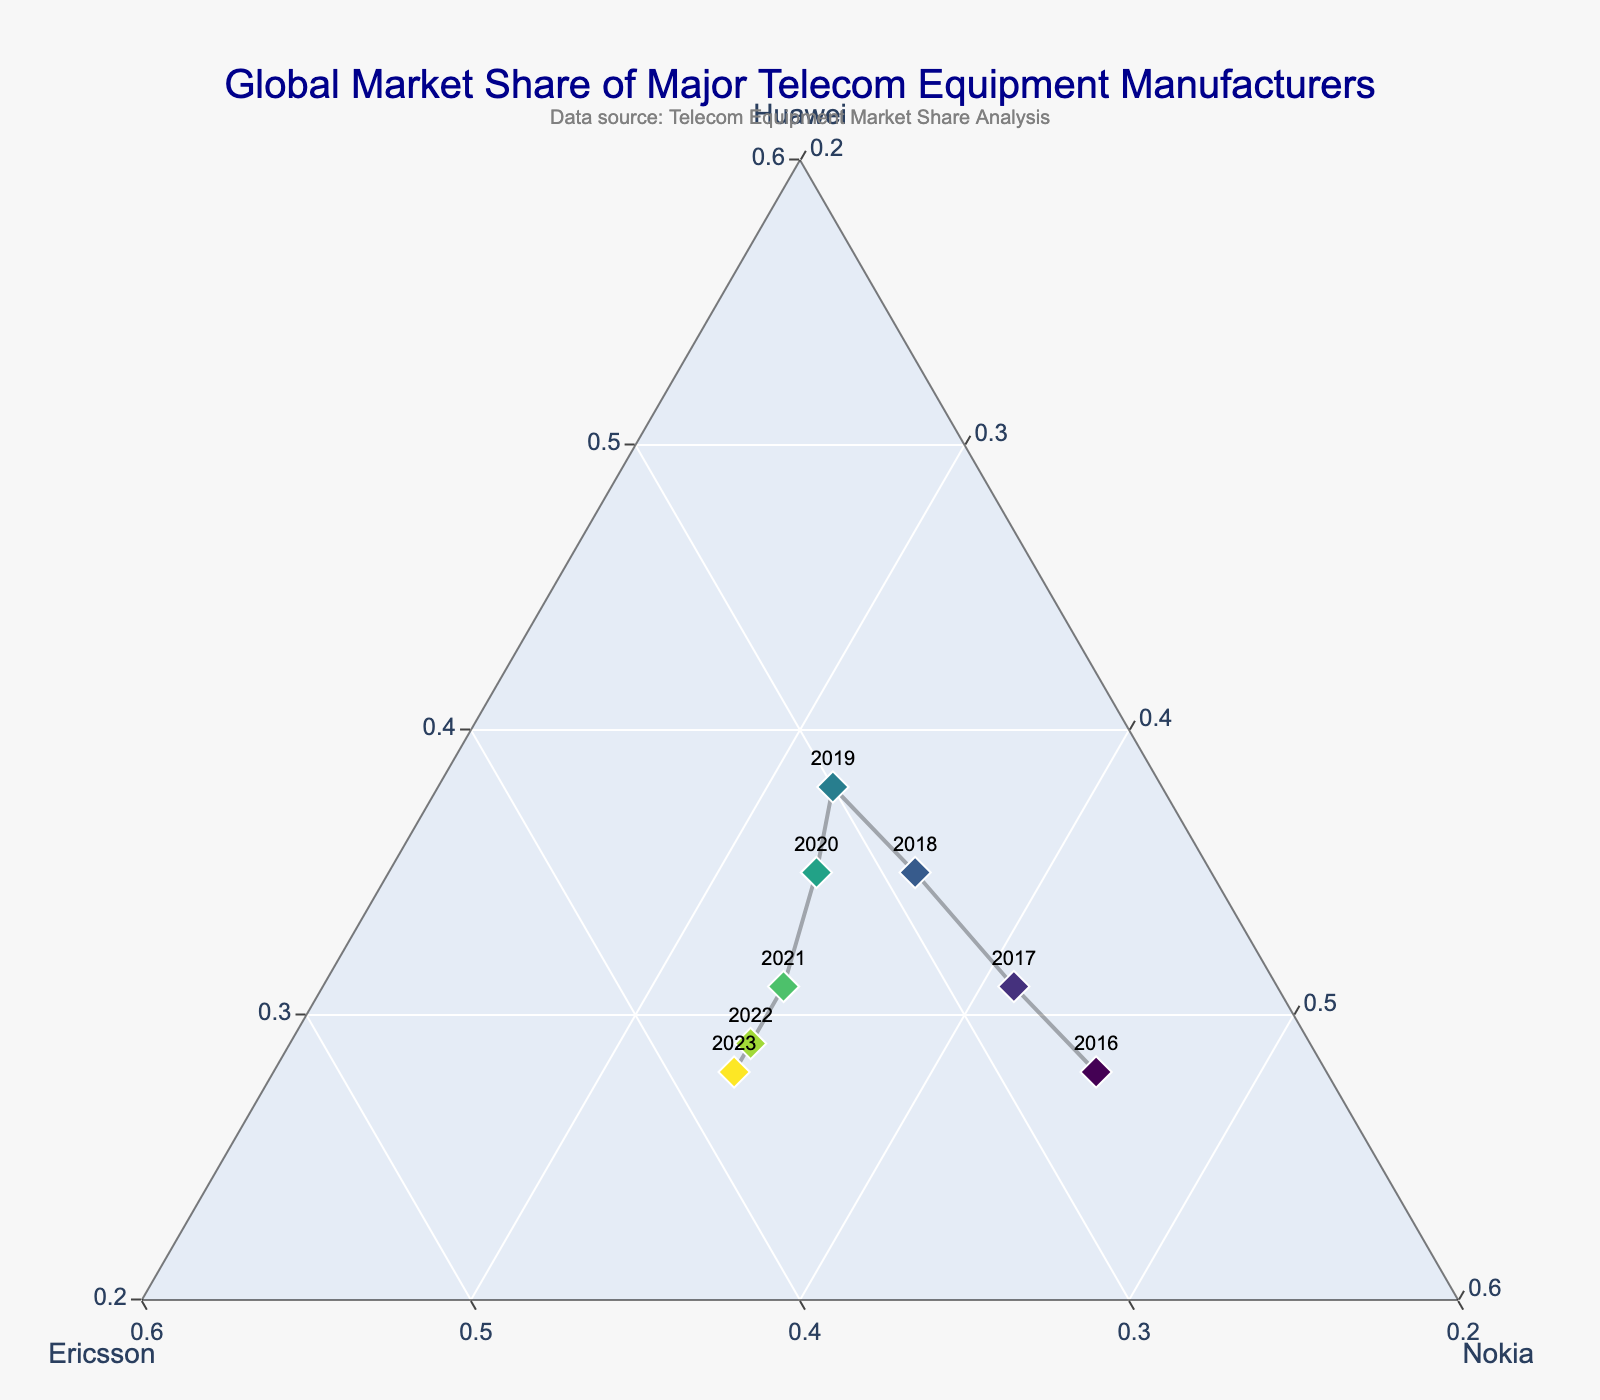What is the overall trend in Huawei’s market share from 2016 to 2023? To identify the trend, look at the position of each point labeled with the respective year. Huawei's share decreases after peaking around 2019, positioning closer to Nokia's axis in later years.
Answer: Decreasing How does Nokia's market share in 2023 compare to its share in 2016? Nokai’s market share is indicated by points' proximity to the Nokia axis. Compare the positions of the points labeled 2016 and 2023. Nokia's share slightly declines from 2016 to 2023.
Answer: Lower Between Ericsson and Nokia, which saw a more significant increase in market share from 2016 to 2023? Examine the paths from 2016 to 2023. Ericsson’s path increases notably towards its axis, whereas Nokia's remains relatively stable.
Answer: Ericsson Which year depicts the closest market share among the three companies? Look for a point near the center of the triangle. The 2021 point is centrally located, indicating more balanced shares among the companies.
Answer: 2021 What year did Huawei have its highest market share? Identify the point closest to the Huawei axis. The 2019 point is closest to the Huawei axis, indicating its peak share.
Answer: 2019 How does the diversity in market share distribution trend over the years? Diversity in distribution can be inferred from symmetry and centrality of points over the years. Early years are more skewed, moving to more evenly distributed shares in recent years.
Answer: Increasingly balanced Which two years have the most similar market share distributions? Identify the points with the minimal spatial difference. 2022 and 2023 are closest, indicating similar market share distributions.
Answer: 2022 and 2023 Compare the market share shifts from 2020 to 2021 for all three companies. Assess the shift in position from 2020 to 2021 for all companies. Huawei decreases, Ericsson significantly increases, and Nokia marginally increases.
Answer: Huawei decreased, Ericsson increased, Nokia slightly increased What's the overall market share change pattern for Ericsson from 2016 to 2023? Trace the points labeled for Ericsson from 2016 to 2023. Ericsson’s share steadily rises towards its axis over the years.
Answer: Increasing 